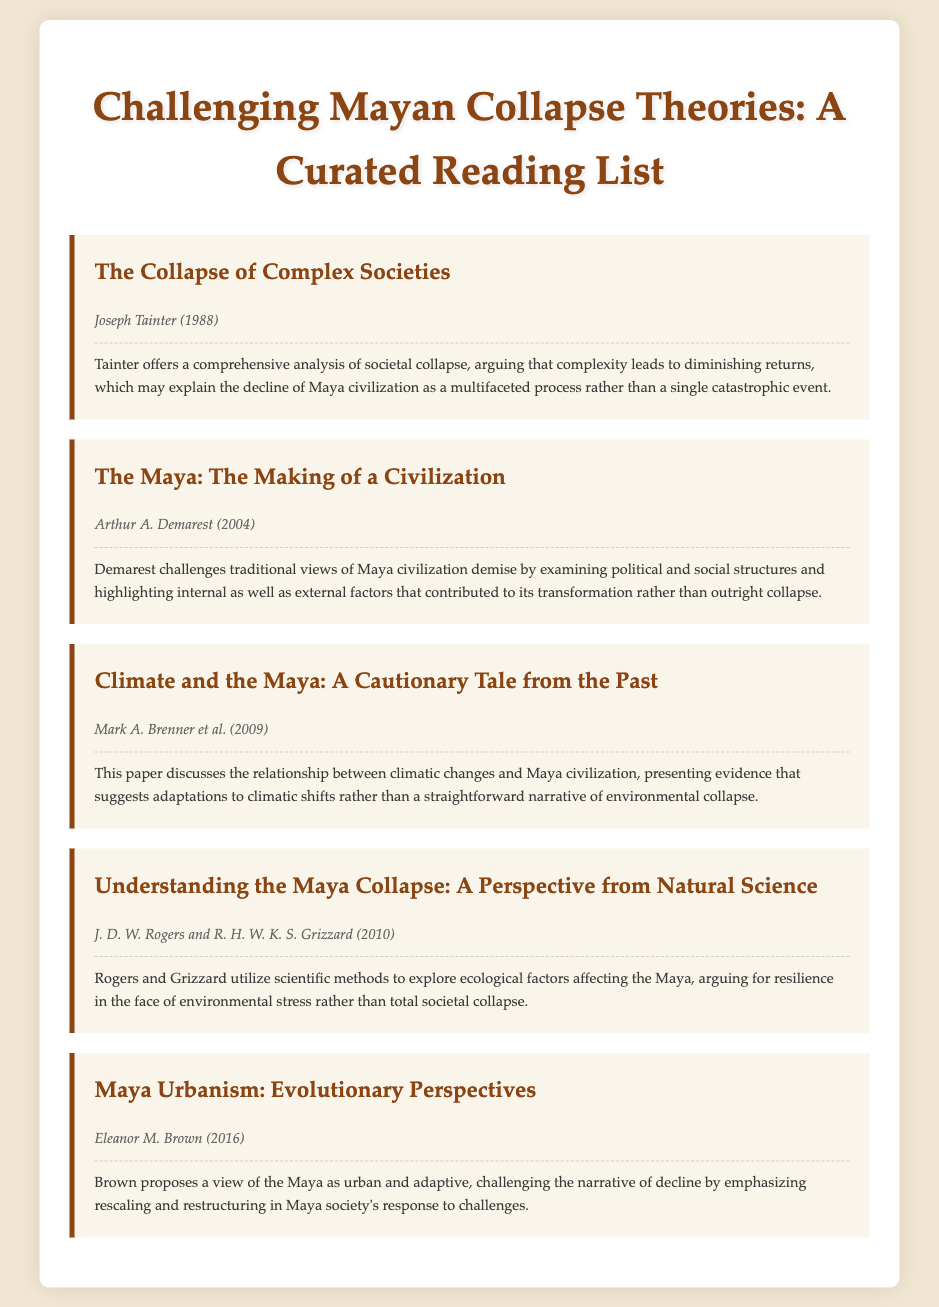What is the title of Joseph Tainter's work? The title of Joseph Tainter's work is listed in the document and is "The Collapse of Complex Societies."
Answer: The Collapse of Complex Societies Who is the author of "The Maya: The Making of a Civilization"? The document specifies that the author of "The Maya: The Making of a Civilization" is Arthur A. Demarest.
Answer: Arthur A. Demarest In what year was "Climate and the Maya: A Cautionary Tale from the Past" published? The document indicates the publication year for this article is 2009.
Answer: 2009 What main theme does Eleanor M. Brown's work focus on? The document states that Brown's work proposes a view of the Maya as urban and adaptive, focusing on rescaling and restructuring.
Answer: Urban and adaptive Which author argues for resilience in the face of environmental stress? According to the document, J. D. W. Rogers and R. H. W. K. S. Grizzard argue for resilience in the face of environmental stress.
Answer: J. D. W. Rogers and R. H. W. K. S. Grizzard What type of evidence do Brenner and colleagues present regarding climatic changes affecting the Maya? The document suggests that Brenner et al. present evidence indicating adaptations to climatic shifts rather than a straightforward narrative of environmental collapse.
Answer: Adaptations to climatic shifts 